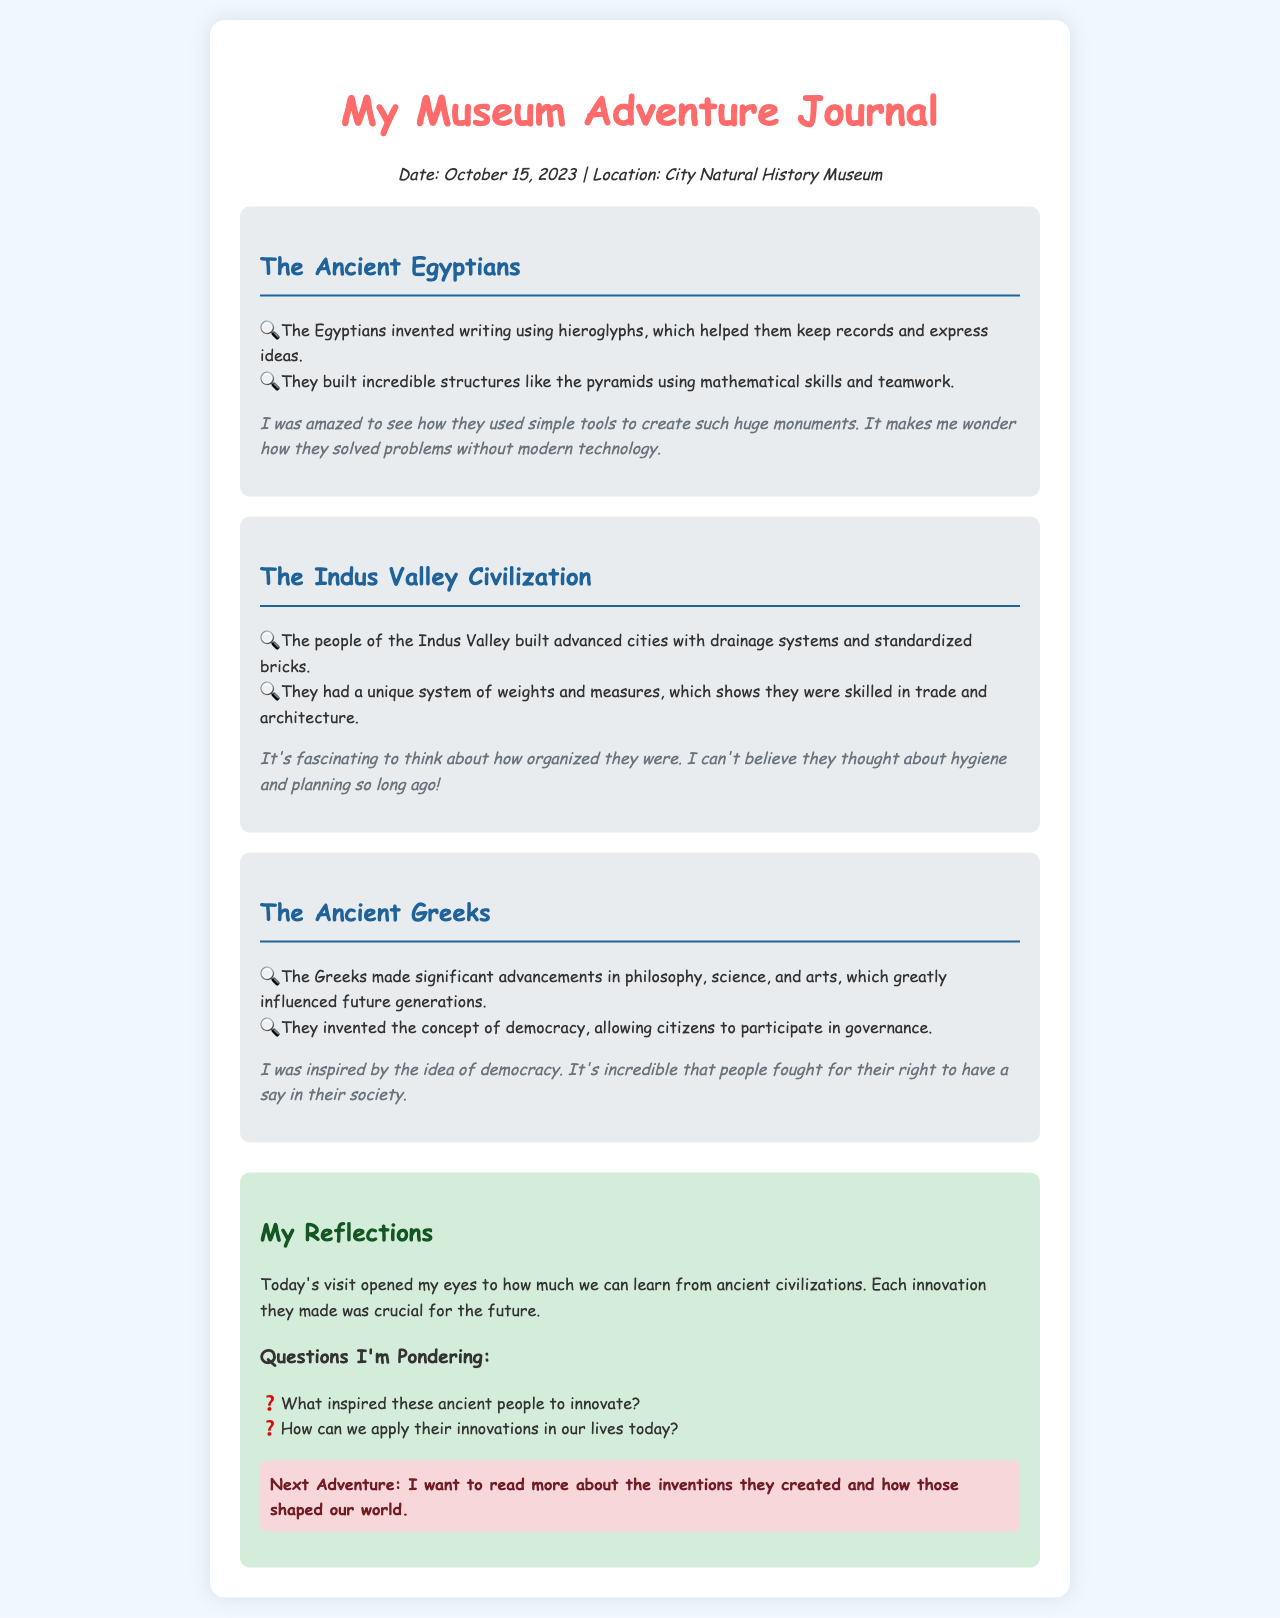What was the date of the museum visit? The date is mentioned at the top of the document under the date-location section.
Answer: October 15, 2023 Which civilization is associated with hieroglyphs? The document states that the Egyptians invented writing using hieroglyphs.
Answer: The Ancient Egyptians What notable structure did the Egyptians build? The document notes that they built incredible structures like the pyramids.
Answer: Pyramids What feature distinguished the Indus Valley cities? The document highlights their advanced cities with drainage systems and standardized bricks.
Answer: Drainage systems What system did the Indus Valley Civilization have for trade? The document mentions that they had a unique system of weights and measures.
Answer: Weights and measures What concept did the Ancient Greeks invent? The document states that they invented the concept of democracy.
Answer: Democracy What was one of the author's thoughts about the Egyptian innovations? The document captures the author's amazement at how Egyptians used simple tools to create huge monuments.
Answer: Simple tools What are the author’s reflections about Ancient civilizations? The author reflects on how much we can learn from ancient civilizations and their innovations.
Answer: Learn from ancient civilizations What is the author's next adventure? The document specifies that the author wants to read more about the inventions created by ancient civilizations.
Answer: Read more about inventions 